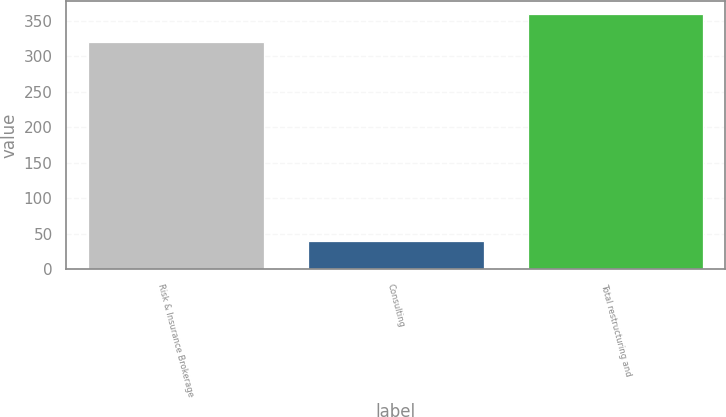Convert chart. <chart><loc_0><loc_0><loc_500><loc_500><bar_chart><fcel>Risk & Insurance Brokerage<fcel>Consulting<fcel>Total restructuring and<nl><fcel>320<fcel>40<fcel>360<nl></chart> 